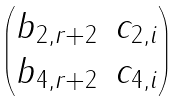<formula> <loc_0><loc_0><loc_500><loc_500>\begin{pmatrix} b _ { 2 , r + 2 } & c _ { 2 , i } \\ b _ { 4 , r + 2 } & c _ { 4 , i } \end{pmatrix}</formula> 